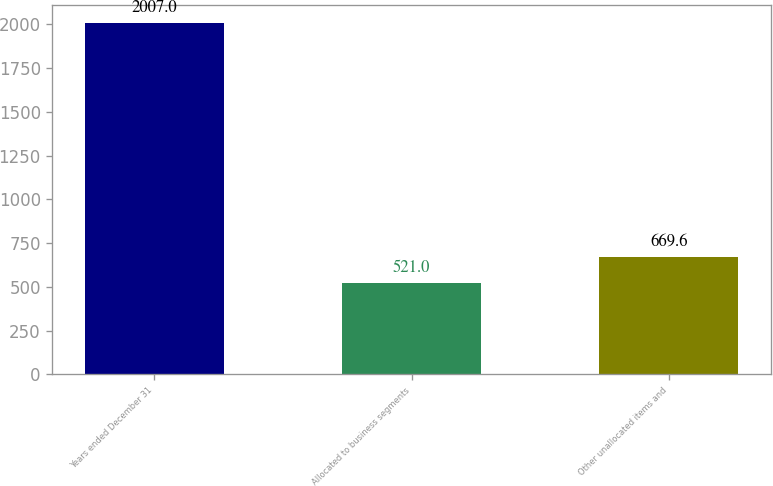Convert chart to OTSL. <chart><loc_0><loc_0><loc_500><loc_500><bar_chart><fcel>Years ended December 31<fcel>Allocated to business segments<fcel>Other unallocated items and<nl><fcel>2007<fcel>521<fcel>669.6<nl></chart> 